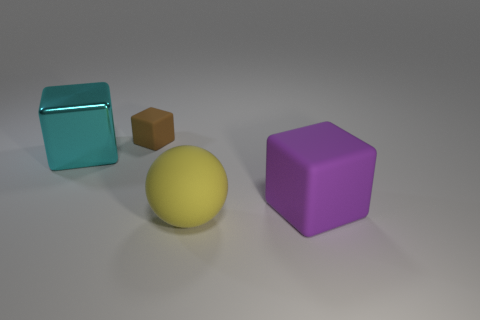Subtract all big purple rubber cubes. How many cubes are left? 2 Add 2 large green shiny things. How many objects exist? 6 Subtract all cubes. How many objects are left? 1 Subtract all red blocks. Subtract all brown balls. How many blocks are left? 3 Add 2 big rubber balls. How many big rubber balls are left? 3 Add 3 brown metal blocks. How many brown metal blocks exist? 3 Subtract 1 brown blocks. How many objects are left? 3 Subtract all cyan objects. Subtract all spheres. How many objects are left? 2 